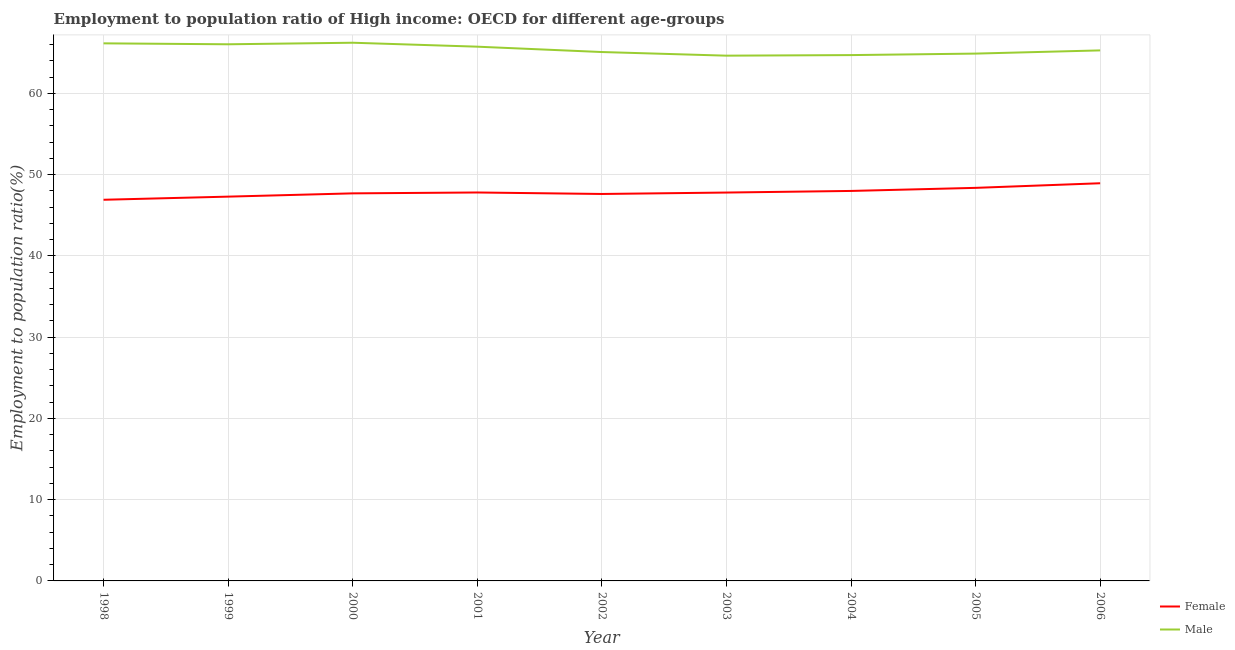How many different coloured lines are there?
Offer a terse response. 2. Does the line corresponding to employment to population ratio(female) intersect with the line corresponding to employment to population ratio(male)?
Your answer should be compact. No. Is the number of lines equal to the number of legend labels?
Your response must be concise. Yes. What is the employment to population ratio(male) in 2001?
Provide a short and direct response. 65.74. Across all years, what is the maximum employment to population ratio(male)?
Ensure brevity in your answer.  66.22. Across all years, what is the minimum employment to population ratio(female)?
Your answer should be compact. 46.9. In which year was the employment to population ratio(male) maximum?
Your response must be concise. 2000. In which year was the employment to population ratio(male) minimum?
Your answer should be very brief. 2003. What is the total employment to population ratio(female) in the graph?
Your response must be concise. 430.36. What is the difference between the employment to population ratio(female) in 2003 and that in 2005?
Provide a succinct answer. -0.58. What is the difference between the employment to population ratio(male) in 2005 and the employment to population ratio(female) in 2004?
Your answer should be very brief. 16.9. What is the average employment to population ratio(male) per year?
Offer a terse response. 65.41. In the year 2001, what is the difference between the employment to population ratio(female) and employment to population ratio(male)?
Keep it short and to the point. -17.94. What is the ratio of the employment to population ratio(male) in 1998 to that in 2004?
Provide a succinct answer. 1.02. Is the employment to population ratio(female) in 2003 less than that in 2005?
Your answer should be compact. Yes. What is the difference between the highest and the second highest employment to population ratio(female)?
Offer a very short reply. 0.57. What is the difference between the highest and the lowest employment to population ratio(male)?
Your response must be concise. 1.59. Is the employment to population ratio(female) strictly greater than the employment to population ratio(male) over the years?
Your response must be concise. No. Is the employment to population ratio(female) strictly less than the employment to population ratio(male) over the years?
Provide a short and direct response. Yes. Are the values on the major ticks of Y-axis written in scientific E-notation?
Your response must be concise. No. Does the graph contain grids?
Your response must be concise. Yes. What is the title of the graph?
Offer a very short reply. Employment to population ratio of High income: OECD for different age-groups. Does "GDP at market prices" appear as one of the legend labels in the graph?
Give a very brief answer. No. What is the Employment to population ratio(%) of Female in 1998?
Make the answer very short. 46.9. What is the Employment to population ratio(%) in Male in 1998?
Your response must be concise. 66.15. What is the Employment to population ratio(%) of Female in 1999?
Make the answer very short. 47.29. What is the Employment to population ratio(%) in Male in 1999?
Provide a succinct answer. 66.03. What is the Employment to population ratio(%) of Female in 2000?
Provide a short and direct response. 47.69. What is the Employment to population ratio(%) in Male in 2000?
Give a very brief answer. 66.22. What is the Employment to population ratio(%) in Female in 2001?
Keep it short and to the point. 47.8. What is the Employment to population ratio(%) of Male in 2001?
Give a very brief answer. 65.74. What is the Employment to population ratio(%) in Female in 2002?
Give a very brief answer. 47.61. What is the Employment to population ratio(%) of Male in 2002?
Keep it short and to the point. 65.08. What is the Employment to population ratio(%) in Female in 2003?
Provide a short and direct response. 47.79. What is the Employment to population ratio(%) in Male in 2003?
Your answer should be compact. 64.63. What is the Employment to population ratio(%) in Female in 2004?
Ensure brevity in your answer.  47.99. What is the Employment to population ratio(%) in Male in 2004?
Give a very brief answer. 64.7. What is the Employment to population ratio(%) in Female in 2005?
Your answer should be very brief. 48.37. What is the Employment to population ratio(%) of Male in 2005?
Offer a very short reply. 64.89. What is the Employment to population ratio(%) of Female in 2006?
Your answer should be very brief. 48.93. What is the Employment to population ratio(%) in Male in 2006?
Your answer should be compact. 65.28. Across all years, what is the maximum Employment to population ratio(%) in Female?
Offer a terse response. 48.93. Across all years, what is the maximum Employment to population ratio(%) of Male?
Your answer should be compact. 66.22. Across all years, what is the minimum Employment to population ratio(%) of Female?
Keep it short and to the point. 46.9. Across all years, what is the minimum Employment to population ratio(%) in Male?
Your answer should be very brief. 64.63. What is the total Employment to population ratio(%) in Female in the graph?
Keep it short and to the point. 430.36. What is the total Employment to population ratio(%) in Male in the graph?
Your answer should be very brief. 588.72. What is the difference between the Employment to population ratio(%) in Female in 1998 and that in 1999?
Give a very brief answer. -0.39. What is the difference between the Employment to population ratio(%) in Male in 1998 and that in 1999?
Give a very brief answer. 0.12. What is the difference between the Employment to population ratio(%) in Female in 1998 and that in 2000?
Offer a terse response. -0.79. What is the difference between the Employment to population ratio(%) of Male in 1998 and that in 2000?
Keep it short and to the point. -0.08. What is the difference between the Employment to population ratio(%) in Female in 1998 and that in 2001?
Your answer should be compact. -0.9. What is the difference between the Employment to population ratio(%) of Male in 1998 and that in 2001?
Make the answer very short. 0.41. What is the difference between the Employment to population ratio(%) of Female in 1998 and that in 2002?
Make the answer very short. -0.71. What is the difference between the Employment to population ratio(%) in Male in 1998 and that in 2002?
Give a very brief answer. 1.07. What is the difference between the Employment to population ratio(%) of Female in 1998 and that in 2003?
Your answer should be very brief. -0.89. What is the difference between the Employment to population ratio(%) in Male in 1998 and that in 2003?
Your answer should be very brief. 1.52. What is the difference between the Employment to population ratio(%) in Female in 1998 and that in 2004?
Offer a very short reply. -1.09. What is the difference between the Employment to population ratio(%) of Male in 1998 and that in 2004?
Make the answer very short. 1.45. What is the difference between the Employment to population ratio(%) in Female in 1998 and that in 2005?
Provide a short and direct response. -1.47. What is the difference between the Employment to population ratio(%) of Male in 1998 and that in 2005?
Ensure brevity in your answer.  1.26. What is the difference between the Employment to population ratio(%) in Female in 1998 and that in 2006?
Keep it short and to the point. -2.03. What is the difference between the Employment to population ratio(%) of Male in 1998 and that in 2006?
Provide a short and direct response. 0.87. What is the difference between the Employment to population ratio(%) of Female in 1999 and that in 2000?
Give a very brief answer. -0.4. What is the difference between the Employment to population ratio(%) of Male in 1999 and that in 2000?
Provide a short and direct response. -0.19. What is the difference between the Employment to population ratio(%) in Female in 1999 and that in 2001?
Make the answer very short. -0.51. What is the difference between the Employment to population ratio(%) in Male in 1999 and that in 2001?
Provide a short and direct response. 0.3. What is the difference between the Employment to population ratio(%) of Female in 1999 and that in 2002?
Your answer should be very brief. -0.33. What is the difference between the Employment to population ratio(%) of Male in 1999 and that in 2002?
Make the answer very short. 0.95. What is the difference between the Employment to population ratio(%) in Female in 1999 and that in 2003?
Your answer should be very brief. -0.5. What is the difference between the Employment to population ratio(%) in Male in 1999 and that in 2003?
Make the answer very short. 1.4. What is the difference between the Employment to population ratio(%) in Female in 1999 and that in 2004?
Give a very brief answer. -0.7. What is the difference between the Employment to population ratio(%) of Male in 1999 and that in 2004?
Offer a terse response. 1.33. What is the difference between the Employment to population ratio(%) in Female in 1999 and that in 2005?
Make the answer very short. -1.08. What is the difference between the Employment to population ratio(%) of Male in 1999 and that in 2005?
Keep it short and to the point. 1.15. What is the difference between the Employment to population ratio(%) of Female in 1999 and that in 2006?
Provide a short and direct response. -1.65. What is the difference between the Employment to population ratio(%) in Male in 1999 and that in 2006?
Offer a terse response. 0.75. What is the difference between the Employment to population ratio(%) in Female in 2000 and that in 2001?
Ensure brevity in your answer.  -0.11. What is the difference between the Employment to population ratio(%) in Male in 2000 and that in 2001?
Your response must be concise. 0.49. What is the difference between the Employment to population ratio(%) of Female in 2000 and that in 2002?
Offer a very short reply. 0.07. What is the difference between the Employment to population ratio(%) of Male in 2000 and that in 2002?
Give a very brief answer. 1.15. What is the difference between the Employment to population ratio(%) in Female in 2000 and that in 2003?
Your answer should be very brief. -0.1. What is the difference between the Employment to population ratio(%) in Male in 2000 and that in 2003?
Provide a succinct answer. 1.59. What is the difference between the Employment to population ratio(%) in Female in 2000 and that in 2004?
Make the answer very short. -0.3. What is the difference between the Employment to population ratio(%) of Male in 2000 and that in 2004?
Offer a terse response. 1.52. What is the difference between the Employment to population ratio(%) of Female in 2000 and that in 2005?
Make the answer very short. -0.68. What is the difference between the Employment to population ratio(%) in Male in 2000 and that in 2005?
Provide a succinct answer. 1.34. What is the difference between the Employment to population ratio(%) in Female in 2000 and that in 2006?
Offer a terse response. -1.24. What is the difference between the Employment to population ratio(%) of Male in 2000 and that in 2006?
Your response must be concise. 0.94. What is the difference between the Employment to population ratio(%) of Female in 2001 and that in 2002?
Offer a terse response. 0.18. What is the difference between the Employment to population ratio(%) of Male in 2001 and that in 2002?
Provide a succinct answer. 0.66. What is the difference between the Employment to population ratio(%) in Female in 2001 and that in 2003?
Offer a terse response. 0.01. What is the difference between the Employment to population ratio(%) of Male in 2001 and that in 2003?
Keep it short and to the point. 1.11. What is the difference between the Employment to population ratio(%) of Female in 2001 and that in 2004?
Provide a short and direct response. -0.19. What is the difference between the Employment to population ratio(%) of Male in 2001 and that in 2004?
Offer a terse response. 1.04. What is the difference between the Employment to population ratio(%) of Female in 2001 and that in 2005?
Keep it short and to the point. -0.57. What is the difference between the Employment to population ratio(%) in Male in 2001 and that in 2005?
Offer a very short reply. 0.85. What is the difference between the Employment to population ratio(%) in Female in 2001 and that in 2006?
Offer a very short reply. -1.13. What is the difference between the Employment to population ratio(%) of Male in 2001 and that in 2006?
Make the answer very short. 0.46. What is the difference between the Employment to population ratio(%) in Female in 2002 and that in 2003?
Ensure brevity in your answer.  -0.17. What is the difference between the Employment to population ratio(%) of Male in 2002 and that in 2003?
Provide a succinct answer. 0.45. What is the difference between the Employment to population ratio(%) in Female in 2002 and that in 2004?
Offer a terse response. -0.37. What is the difference between the Employment to population ratio(%) in Male in 2002 and that in 2004?
Keep it short and to the point. 0.38. What is the difference between the Employment to population ratio(%) of Female in 2002 and that in 2005?
Offer a terse response. -0.75. What is the difference between the Employment to population ratio(%) of Male in 2002 and that in 2005?
Offer a very short reply. 0.19. What is the difference between the Employment to population ratio(%) of Female in 2002 and that in 2006?
Keep it short and to the point. -1.32. What is the difference between the Employment to population ratio(%) of Male in 2002 and that in 2006?
Offer a terse response. -0.2. What is the difference between the Employment to population ratio(%) in Female in 2003 and that in 2004?
Your answer should be compact. -0.2. What is the difference between the Employment to population ratio(%) in Male in 2003 and that in 2004?
Your response must be concise. -0.07. What is the difference between the Employment to population ratio(%) in Female in 2003 and that in 2005?
Your response must be concise. -0.58. What is the difference between the Employment to population ratio(%) of Male in 2003 and that in 2005?
Give a very brief answer. -0.26. What is the difference between the Employment to population ratio(%) in Female in 2003 and that in 2006?
Provide a succinct answer. -1.14. What is the difference between the Employment to population ratio(%) of Male in 2003 and that in 2006?
Offer a terse response. -0.65. What is the difference between the Employment to population ratio(%) in Female in 2004 and that in 2005?
Ensure brevity in your answer.  -0.38. What is the difference between the Employment to population ratio(%) in Male in 2004 and that in 2005?
Provide a succinct answer. -0.18. What is the difference between the Employment to population ratio(%) in Female in 2004 and that in 2006?
Ensure brevity in your answer.  -0.94. What is the difference between the Employment to population ratio(%) in Male in 2004 and that in 2006?
Your answer should be compact. -0.58. What is the difference between the Employment to population ratio(%) of Female in 2005 and that in 2006?
Your response must be concise. -0.57. What is the difference between the Employment to population ratio(%) in Male in 2005 and that in 2006?
Ensure brevity in your answer.  -0.39. What is the difference between the Employment to population ratio(%) of Female in 1998 and the Employment to population ratio(%) of Male in 1999?
Your response must be concise. -19.13. What is the difference between the Employment to population ratio(%) of Female in 1998 and the Employment to population ratio(%) of Male in 2000?
Give a very brief answer. -19.32. What is the difference between the Employment to population ratio(%) in Female in 1998 and the Employment to population ratio(%) in Male in 2001?
Provide a short and direct response. -18.84. What is the difference between the Employment to population ratio(%) of Female in 1998 and the Employment to population ratio(%) of Male in 2002?
Make the answer very short. -18.18. What is the difference between the Employment to population ratio(%) in Female in 1998 and the Employment to population ratio(%) in Male in 2003?
Keep it short and to the point. -17.73. What is the difference between the Employment to population ratio(%) of Female in 1998 and the Employment to population ratio(%) of Male in 2004?
Give a very brief answer. -17.8. What is the difference between the Employment to population ratio(%) of Female in 1998 and the Employment to population ratio(%) of Male in 2005?
Give a very brief answer. -17.99. What is the difference between the Employment to population ratio(%) of Female in 1998 and the Employment to population ratio(%) of Male in 2006?
Make the answer very short. -18.38. What is the difference between the Employment to population ratio(%) of Female in 1999 and the Employment to population ratio(%) of Male in 2000?
Make the answer very short. -18.94. What is the difference between the Employment to population ratio(%) in Female in 1999 and the Employment to population ratio(%) in Male in 2001?
Your response must be concise. -18.45. What is the difference between the Employment to population ratio(%) in Female in 1999 and the Employment to population ratio(%) in Male in 2002?
Provide a short and direct response. -17.79. What is the difference between the Employment to population ratio(%) of Female in 1999 and the Employment to population ratio(%) of Male in 2003?
Make the answer very short. -17.35. What is the difference between the Employment to population ratio(%) in Female in 1999 and the Employment to population ratio(%) in Male in 2004?
Make the answer very short. -17.42. What is the difference between the Employment to population ratio(%) of Female in 1999 and the Employment to population ratio(%) of Male in 2005?
Your answer should be very brief. -17.6. What is the difference between the Employment to population ratio(%) in Female in 1999 and the Employment to population ratio(%) in Male in 2006?
Offer a terse response. -17.99. What is the difference between the Employment to population ratio(%) of Female in 2000 and the Employment to population ratio(%) of Male in 2001?
Provide a succinct answer. -18.05. What is the difference between the Employment to population ratio(%) in Female in 2000 and the Employment to population ratio(%) in Male in 2002?
Make the answer very short. -17.39. What is the difference between the Employment to population ratio(%) of Female in 2000 and the Employment to population ratio(%) of Male in 2003?
Offer a very short reply. -16.94. What is the difference between the Employment to population ratio(%) of Female in 2000 and the Employment to population ratio(%) of Male in 2004?
Provide a short and direct response. -17.01. What is the difference between the Employment to population ratio(%) of Female in 2000 and the Employment to population ratio(%) of Male in 2005?
Your response must be concise. -17.2. What is the difference between the Employment to population ratio(%) in Female in 2000 and the Employment to population ratio(%) in Male in 2006?
Your response must be concise. -17.59. What is the difference between the Employment to population ratio(%) in Female in 2001 and the Employment to population ratio(%) in Male in 2002?
Offer a very short reply. -17.28. What is the difference between the Employment to population ratio(%) of Female in 2001 and the Employment to population ratio(%) of Male in 2003?
Provide a succinct answer. -16.84. What is the difference between the Employment to population ratio(%) in Female in 2001 and the Employment to population ratio(%) in Male in 2004?
Provide a short and direct response. -16.91. What is the difference between the Employment to population ratio(%) of Female in 2001 and the Employment to population ratio(%) of Male in 2005?
Offer a terse response. -17.09. What is the difference between the Employment to population ratio(%) of Female in 2001 and the Employment to population ratio(%) of Male in 2006?
Provide a succinct answer. -17.48. What is the difference between the Employment to population ratio(%) in Female in 2002 and the Employment to population ratio(%) in Male in 2003?
Keep it short and to the point. -17.02. What is the difference between the Employment to population ratio(%) in Female in 2002 and the Employment to population ratio(%) in Male in 2004?
Provide a succinct answer. -17.09. What is the difference between the Employment to population ratio(%) of Female in 2002 and the Employment to population ratio(%) of Male in 2005?
Your answer should be compact. -17.27. What is the difference between the Employment to population ratio(%) of Female in 2002 and the Employment to population ratio(%) of Male in 2006?
Your answer should be very brief. -17.67. What is the difference between the Employment to population ratio(%) in Female in 2003 and the Employment to population ratio(%) in Male in 2004?
Give a very brief answer. -16.91. What is the difference between the Employment to population ratio(%) of Female in 2003 and the Employment to population ratio(%) of Male in 2005?
Make the answer very short. -17.1. What is the difference between the Employment to population ratio(%) of Female in 2003 and the Employment to population ratio(%) of Male in 2006?
Provide a succinct answer. -17.49. What is the difference between the Employment to population ratio(%) in Female in 2004 and the Employment to population ratio(%) in Male in 2005?
Offer a terse response. -16.9. What is the difference between the Employment to population ratio(%) in Female in 2004 and the Employment to population ratio(%) in Male in 2006?
Offer a terse response. -17.29. What is the difference between the Employment to population ratio(%) in Female in 2005 and the Employment to population ratio(%) in Male in 2006?
Your answer should be compact. -16.91. What is the average Employment to population ratio(%) of Female per year?
Make the answer very short. 47.82. What is the average Employment to population ratio(%) in Male per year?
Provide a short and direct response. 65.41. In the year 1998, what is the difference between the Employment to population ratio(%) in Female and Employment to population ratio(%) in Male?
Your answer should be very brief. -19.25. In the year 1999, what is the difference between the Employment to population ratio(%) of Female and Employment to population ratio(%) of Male?
Make the answer very short. -18.75. In the year 2000, what is the difference between the Employment to population ratio(%) in Female and Employment to population ratio(%) in Male?
Your answer should be very brief. -18.54. In the year 2001, what is the difference between the Employment to population ratio(%) of Female and Employment to population ratio(%) of Male?
Make the answer very short. -17.94. In the year 2002, what is the difference between the Employment to population ratio(%) in Female and Employment to population ratio(%) in Male?
Give a very brief answer. -17.47. In the year 2003, what is the difference between the Employment to population ratio(%) of Female and Employment to population ratio(%) of Male?
Offer a terse response. -16.84. In the year 2004, what is the difference between the Employment to population ratio(%) in Female and Employment to population ratio(%) in Male?
Offer a very short reply. -16.72. In the year 2005, what is the difference between the Employment to population ratio(%) of Female and Employment to population ratio(%) of Male?
Offer a terse response. -16.52. In the year 2006, what is the difference between the Employment to population ratio(%) in Female and Employment to population ratio(%) in Male?
Your answer should be very brief. -16.35. What is the ratio of the Employment to population ratio(%) of Male in 1998 to that in 1999?
Your answer should be compact. 1. What is the ratio of the Employment to population ratio(%) of Female in 1998 to that in 2000?
Your answer should be compact. 0.98. What is the ratio of the Employment to population ratio(%) of Female in 1998 to that in 2001?
Offer a very short reply. 0.98. What is the ratio of the Employment to population ratio(%) of Male in 1998 to that in 2002?
Provide a short and direct response. 1.02. What is the ratio of the Employment to population ratio(%) in Female in 1998 to that in 2003?
Provide a short and direct response. 0.98. What is the ratio of the Employment to population ratio(%) in Male in 1998 to that in 2003?
Your answer should be very brief. 1.02. What is the ratio of the Employment to population ratio(%) of Female in 1998 to that in 2004?
Your response must be concise. 0.98. What is the ratio of the Employment to population ratio(%) of Male in 1998 to that in 2004?
Your answer should be very brief. 1.02. What is the ratio of the Employment to population ratio(%) of Female in 1998 to that in 2005?
Give a very brief answer. 0.97. What is the ratio of the Employment to population ratio(%) in Male in 1998 to that in 2005?
Provide a succinct answer. 1.02. What is the ratio of the Employment to population ratio(%) of Female in 1998 to that in 2006?
Give a very brief answer. 0.96. What is the ratio of the Employment to population ratio(%) in Male in 1998 to that in 2006?
Offer a very short reply. 1.01. What is the ratio of the Employment to population ratio(%) in Female in 1999 to that in 2000?
Provide a succinct answer. 0.99. What is the ratio of the Employment to population ratio(%) in Male in 1999 to that in 2000?
Your answer should be very brief. 1. What is the ratio of the Employment to population ratio(%) of Female in 1999 to that in 2001?
Keep it short and to the point. 0.99. What is the ratio of the Employment to population ratio(%) in Female in 1999 to that in 2002?
Your response must be concise. 0.99. What is the ratio of the Employment to population ratio(%) of Male in 1999 to that in 2002?
Offer a very short reply. 1.01. What is the ratio of the Employment to population ratio(%) in Male in 1999 to that in 2003?
Your answer should be compact. 1.02. What is the ratio of the Employment to population ratio(%) in Female in 1999 to that in 2004?
Provide a short and direct response. 0.99. What is the ratio of the Employment to population ratio(%) of Male in 1999 to that in 2004?
Your answer should be very brief. 1.02. What is the ratio of the Employment to population ratio(%) of Female in 1999 to that in 2005?
Offer a terse response. 0.98. What is the ratio of the Employment to population ratio(%) of Male in 1999 to that in 2005?
Your answer should be compact. 1.02. What is the ratio of the Employment to population ratio(%) in Female in 1999 to that in 2006?
Your response must be concise. 0.97. What is the ratio of the Employment to population ratio(%) in Male in 1999 to that in 2006?
Offer a terse response. 1.01. What is the ratio of the Employment to population ratio(%) in Male in 2000 to that in 2001?
Offer a very short reply. 1.01. What is the ratio of the Employment to population ratio(%) in Female in 2000 to that in 2002?
Make the answer very short. 1. What is the ratio of the Employment to population ratio(%) in Male in 2000 to that in 2002?
Make the answer very short. 1.02. What is the ratio of the Employment to population ratio(%) in Male in 2000 to that in 2003?
Your answer should be compact. 1.02. What is the ratio of the Employment to population ratio(%) in Male in 2000 to that in 2004?
Provide a succinct answer. 1.02. What is the ratio of the Employment to population ratio(%) of Male in 2000 to that in 2005?
Provide a short and direct response. 1.02. What is the ratio of the Employment to population ratio(%) of Female in 2000 to that in 2006?
Offer a terse response. 0.97. What is the ratio of the Employment to population ratio(%) in Male in 2000 to that in 2006?
Your answer should be very brief. 1.01. What is the ratio of the Employment to population ratio(%) of Female in 2001 to that in 2002?
Your response must be concise. 1. What is the ratio of the Employment to population ratio(%) of Male in 2001 to that in 2002?
Your answer should be compact. 1.01. What is the ratio of the Employment to population ratio(%) in Male in 2001 to that in 2003?
Your answer should be very brief. 1.02. What is the ratio of the Employment to population ratio(%) in Female in 2001 to that in 2004?
Your answer should be very brief. 1. What is the ratio of the Employment to population ratio(%) of Male in 2001 to that in 2004?
Make the answer very short. 1.02. What is the ratio of the Employment to population ratio(%) of Male in 2001 to that in 2005?
Ensure brevity in your answer.  1.01. What is the ratio of the Employment to population ratio(%) of Female in 2001 to that in 2006?
Provide a succinct answer. 0.98. What is the ratio of the Employment to population ratio(%) of Female in 2002 to that in 2004?
Your response must be concise. 0.99. What is the ratio of the Employment to population ratio(%) of Male in 2002 to that in 2004?
Your response must be concise. 1.01. What is the ratio of the Employment to population ratio(%) in Female in 2002 to that in 2005?
Offer a very short reply. 0.98. What is the ratio of the Employment to population ratio(%) in Female in 2002 to that in 2006?
Make the answer very short. 0.97. What is the ratio of the Employment to population ratio(%) of Male in 2002 to that in 2006?
Keep it short and to the point. 1. What is the ratio of the Employment to population ratio(%) of Female in 2003 to that in 2005?
Provide a succinct answer. 0.99. What is the ratio of the Employment to population ratio(%) in Female in 2003 to that in 2006?
Give a very brief answer. 0.98. What is the ratio of the Employment to population ratio(%) of Female in 2004 to that in 2005?
Give a very brief answer. 0.99. What is the ratio of the Employment to population ratio(%) in Male in 2004 to that in 2005?
Your answer should be compact. 1. What is the ratio of the Employment to population ratio(%) in Female in 2004 to that in 2006?
Provide a short and direct response. 0.98. What is the ratio of the Employment to population ratio(%) of Male in 2004 to that in 2006?
Your answer should be compact. 0.99. What is the ratio of the Employment to population ratio(%) of Female in 2005 to that in 2006?
Your answer should be very brief. 0.99. What is the difference between the highest and the second highest Employment to population ratio(%) of Female?
Ensure brevity in your answer.  0.57. What is the difference between the highest and the second highest Employment to population ratio(%) of Male?
Keep it short and to the point. 0.08. What is the difference between the highest and the lowest Employment to population ratio(%) of Female?
Ensure brevity in your answer.  2.03. What is the difference between the highest and the lowest Employment to population ratio(%) of Male?
Ensure brevity in your answer.  1.59. 